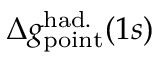Convert formula to latex. <formula><loc_0><loc_0><loc_500><loc_500>\Delta { g } _ { p o i n t } ^ { h a d . } ( 1 s )</formula> 